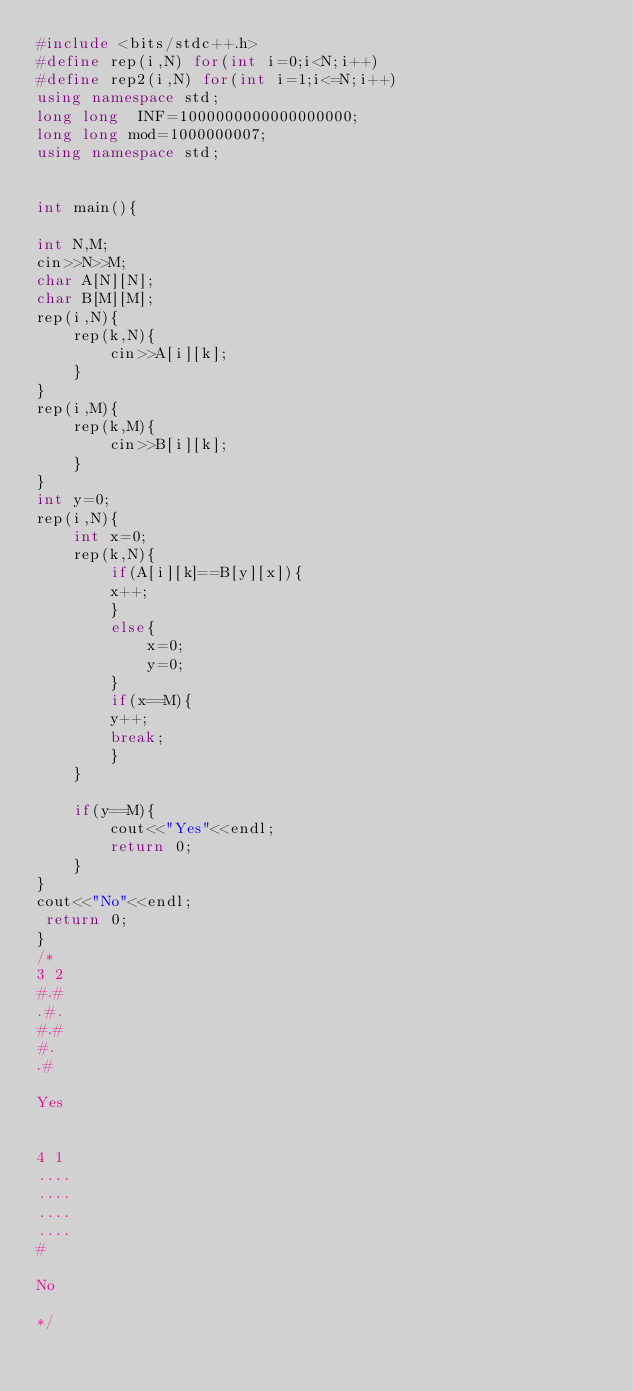<code> <loc_0><loc_0><loc_500><loc_500><_C++_>#include <bits/stdc++.h>
#define rep(i,N) for(int i=0;i<N;i++)
#define rep2(i,N) for(int i=1;i<=N;i++)
using namespace std;
long long  INF=1000000000000000000;
long long mod=1000000007;
using namespace std;


int main(){

int N,M;
cin>>N>>M;
char A[N][N];
char B[M][M];
rep(i,N){
    rep(k,N){
        cin>>A[i][k];
    }
}
rep(i,M){
    rep(k,M){
        cin>>B[i][k];
    }
}
int y=0;
rep(i,N){
    int x=0;
    rep(k,N){
        if(A[i][k]==B[y][x]){
        x++;
        }
        else{
            x=0;
            y=0;
        }
        if(x==M){
        y++;
        break;
        }
    }
    
    if(y==M){
        cout<<"Yes"<<endl;
        return 0;
    }
}
cout<<"No"<<endl;
 return 0;
}
/*
3 2
#.#
.#.
#.#
#.
.#

Yes


4 1
....
....
....
....
#

No

*/
</code> 